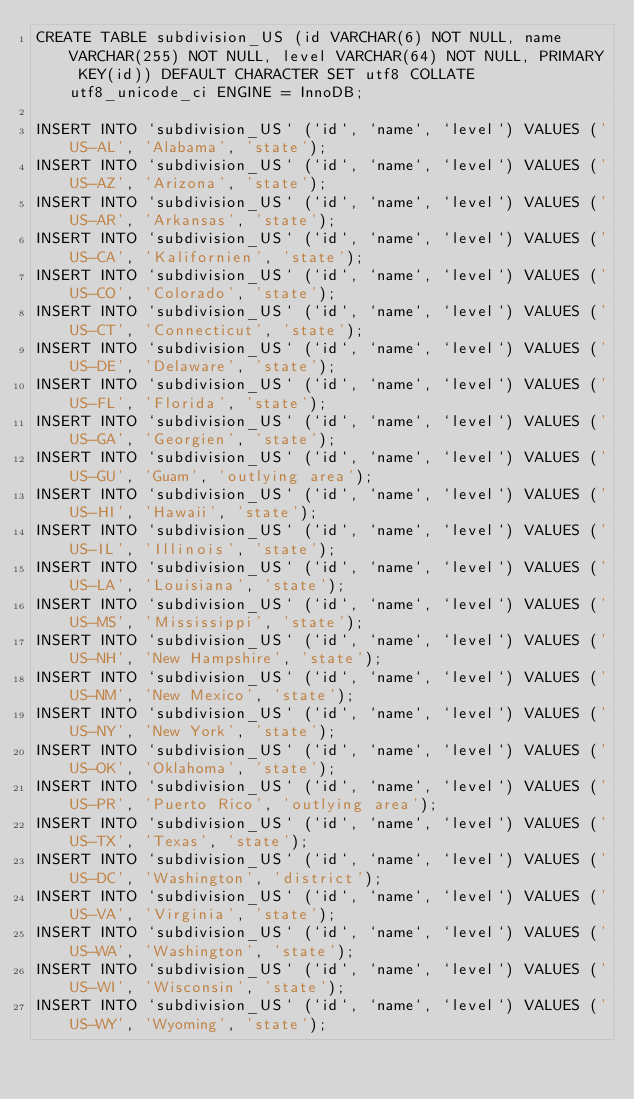Convert code to text. <code><loc_0><loc_0><loc_500><loc_500><_SQL_>CREATE TABLE subdivision_US (id VARCHAR(6) NOT NULL, name VARCHAR(255) NOT NULL, level VARCHAR(64) NOT NULL, PRIMARY KEY(id)) DEFAULT CHARACTER SET utf8 COLLATE utf8_unicode_ci ENGINE = InnoDB;

INSERT INTO `subdivision_US` (`id`, `name`, `level`) VALUES ('US-AL', 'Alabama', 'state');
INSERT INTO `subdivision_US` (`id`, `name`, `level`) VALUES ('US-AZ', 'Arizona', 'state');
INSERT INTO `subdivision_US` (`id`, `name`, `level`) VALUES ('US-AR', 'Arkansas', 'state');
INSERT INTO `subdivision_US` (`id`, `name`, `level`) VALUES ('US-CA', 'Kalifornien', 'state');
INSERT INTO `subdivision_US` (`id`, `name`, `level`) VALUES ('US-CO', 'Colorado', 'state');
INSERT INTO `subdivision_US` (`id`, `name`, `level`) VALUES ('US-CT', 'Connecticut', 'state');
INSERT INTO `subdivision_US` (`id`, `name`, `level`) VALUES ('US-DE', 'Delaware', 'state');
INSERT INTO `subdivision_US` (`id`, `name`, `level`) VALUES ('US-FL', 'Florida', 'state');
INSERT INTO `subdivision_US` (`id`, `name`, `level`) VALUES ('US-GA', 'Georgien', 'state');
INSERT INTO `subdivision_US` (`id`, `name`, `level`) VALUES ('US-GU', 'Guam', 'outlying area');
INSERT INTO `subdivision_US` (`id`, `name`, `level`) VALUES ('US-HI', 'Hawaii', 'state');
INSERT INTO `subdivision_US` (`id`, `name`, `level`) VALUES ('US-IL', 'Illinois', 'state');
INSERT INTO `subdivision_US` (`id`, `name`, `level`) VALUES ('US-LA', 'Louisiana', 'state');
INSERT INTO `subdivision_US` (`id`, `name`, `level`) VALUES ('US-MS', 'Mississippi', 'state');
INSERT INTO `subdivision_US` (`id`, `name`, `level`) VALUES ('US-NH', 'New Hampshire', 'state');
INSERT INTO `subdivision_US` (`id`, `name`, `level`) VALUES ('US-NM', 'New Mexico', 'state');
INSERT INTO `subdivision_US` (`id`, `name`, `level`) VALUES ('US-NY', 'New York', 'state');
INSERT INTO `subdivision_US` (`id`, `name`, `level`) VALUES ('US-OK', 'Oklahoma', 'state');
INSERT INTO `subdivision_US` (`id`, `name`, `level`) VALUES ('US-PR', 'Puerto Rico', 'outlying area');
INSERT INTO `subdivision_US` (`id`, `name`, `level`) VALUES ('US-TX', 'Texas', 'state');
INSERT INTO `subdivision_US` (`id`, `name`, `level`) VALUES ('US-DC', 'Washington', 'district');
INSERT INTO `subdivision_US` (`id`, `name`, `level`) VALUES ('US-VA', 'Virginia', 'state');
INSERT INTO `subdivision_US` (`id`, `name`, `level`) VALUES ('US-WA', 'Washington', 'state');
INSERT INTO `subdivision_US` (`id`, `name`, `level`) VALUES ('US-WI', 'Wisconsin', 'state');
INSERT INTO `subdivision_US` (`id`, `name`, `level`) VALUES ('US-WY', 'Wyoming', 'state');
</code> 